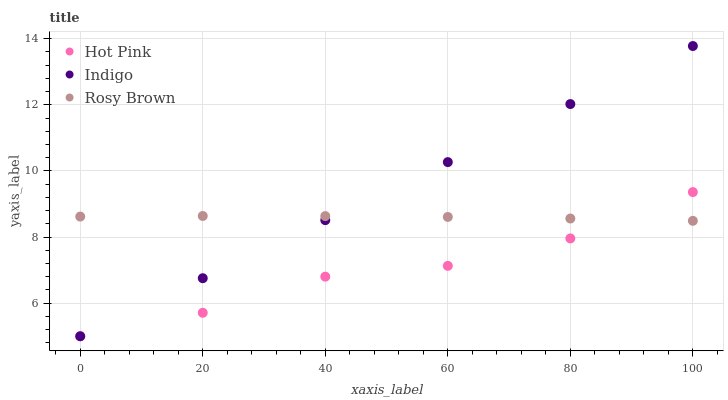Does Hot Pink have the minimum area under the curve?
Answer yes or no. Yes. Does Indigo have the maximum area under the curve?
Answer yes or no. Yes. Does Indigo have the minimum area under the curve?
Answer yes or no. No. Does Hot Pink have the maximum area under the curve?
Answer yes or no. No. Is Indigo the smoothest?
Answer yes or no. Yes. Is Hot Pink the roughest?
Answer yes or no. Yes. Is Hot Pink the smoothest?
Answer yes or no. No. Is Indigo the roughest?
Answer yes or no. No. Does Hot Pink have the lowest value?
Answer yes or no. Yes. Does Indigo have the highest value?
Answer yes or no. Yes. Does Hot Pink have the highest value?
Answer yes or no. No. Does Hot Pink intersect Rosy Brown?
Answer yes or no. Yes. Is Hot Pink less than Rosy Brown?
Answer yes or no. No. Is Hot Pink greater than Rosy Brown?
Answer yes or no. No. 